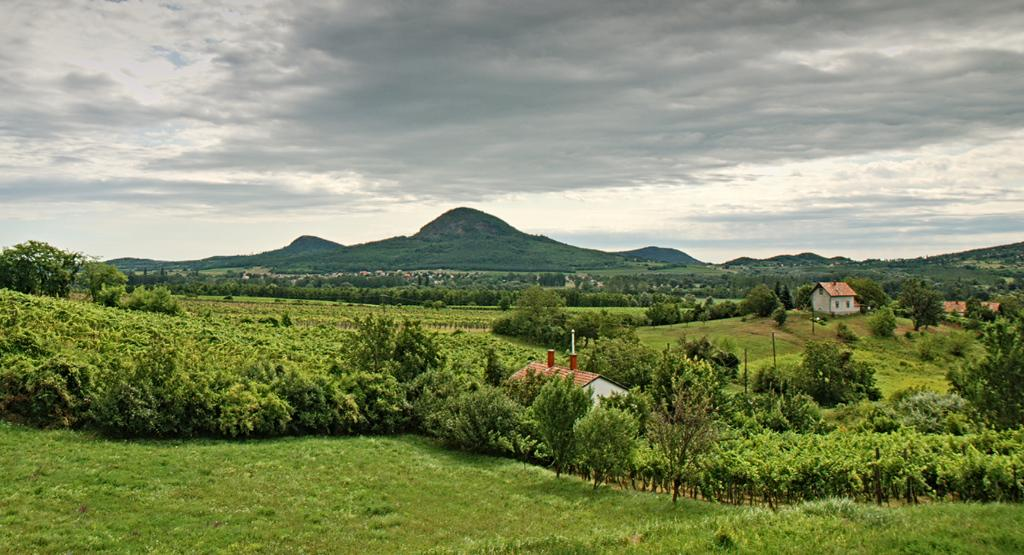What type of structures can be seen in the image? There are houses in the image. What type of vegetation is present in the image? There are trees in the image. What are the tall, thin objects in the image? There are poles in the image. What type of terrain is visible in the image? There are hills in the image. What type of ground cover is present in the image? There is grass in the image. What is visible at the top of the image? The sky is visible at the top of the image. What is the condition of the sky in the image? The sky appears to be cloudy in the image. How many girls are playing with oil in the image? There are no girls or oil present in the image. What type of destruction can be seen in the image? There is no destruction present in the image; it features houses, trees, poles, hills, grass, and a cloudy sky. 